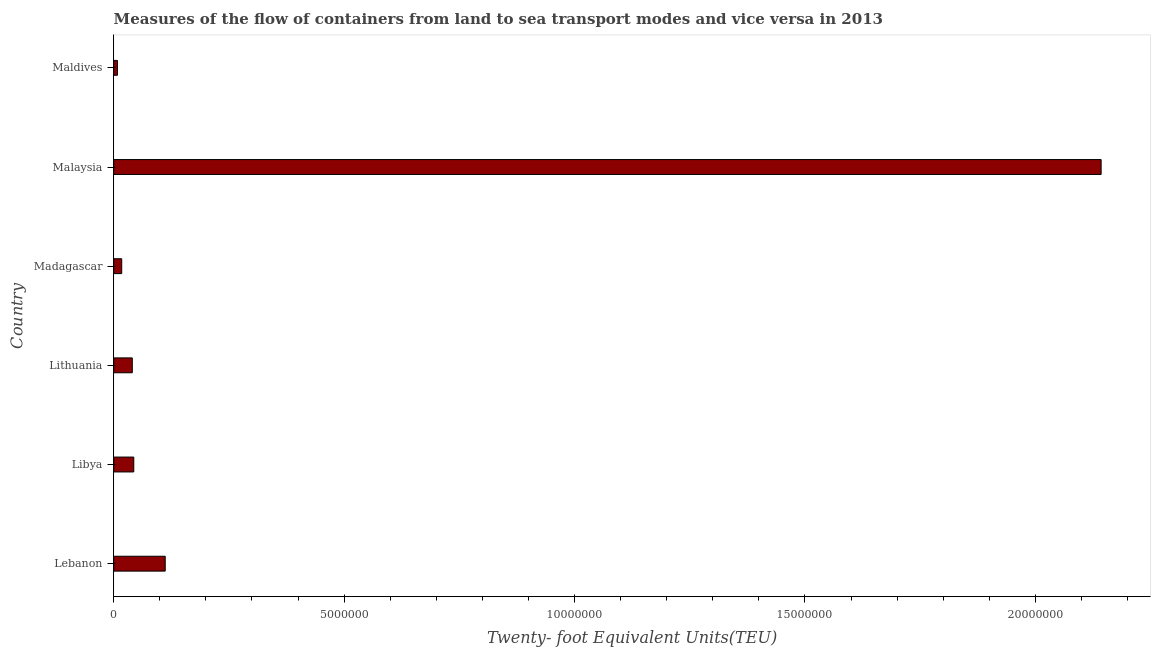Does the graph contain any zero values?
Provide a short and direct response. No. Does the graph contain grids?
Keep it short and to the point. No. What is the title of the graph?
Give a very brief answer. Measures of the flow of containers from land to sea transport modes and vice versa in 2013. What is the label or title of the X-axis?
Your answer should be very brief. Twenty- foot Equivalent Units(TEU). What is the label or title of the Y-axis?
Give a very brief answer. Country. What is the container port traffic in Lebanon?
Your answer should be very brief. 1.12e+06. Across all countries, what is the maximum container port traffic?
Your response must be concise. 2.14e+07. Across all countries, what is the minimum container port traffic?
Provide a succinct answer. 7.97e+04. In which country was the container port traffic maximum?
Give a very brief answer. Malaysia. In which country was the container port traffic minimum?
Offer a terse response. Maldives. What is the sum of the container port traffic?
Your answer should be very brief. 2.36e+07. What is the difference between the container port traffic in Lithuania and Madagascar?
Provide a short and direct response. 2.30e+05. What is the average container port traffic per country?
Make the answer very short. 3.94e+06. What is the median container port traffic?
Provide a succinct answer. 4.19e+05. In how many countries, is the container port traffic greater than 8000000 TEU?
Ensure brevity in your answer.  1. Is the container port traffic in Lebanon less than that in Malaysia?
Provide a succinct answer. Yes. Is the difference between the container port traffic in Lebanon and Malaysia greater than the difference between any two countries?
Offer a terse response. No. What is the difference between the highest and the second highest container port traffic?
Keep it short and to the point. 2.03e+07. Is the sum of the container port traffic in Lebanon and Lithuania greater than the maximum container port traffic across all countries?
Provide a short and direct response. No. What is the difference between the highest and the lowest container port traffic?
Provide a short and direct response. 2.13e+07. In how many countries, is the container port traffic greater than the average container port traffic taken over all countries?
Offer a terse response. 1. How many countries are there in the graph?
Offer a terse response. 6. What is the difference between two consecutive major ticks on the X-axis?
Your answer should be compact. 5.00e+06. What is the Twenty- foot Equivalent Units(TEU) of Lebanon?
Your answer should be very brief. 1.12e+06. What is the Twenty- foot Equivalent Units(TEU) in Libya?
Provide a short and direct response. 4.35e+05. What is the Twenty- foot Equivalent Units(TEU) of Lithuania?
Offer a very short reply. 4.02e+05. What is the Twenty- foot Equivalent Units(TEU) in Madagascar?
Keep it short and to the point. 1.73e+05. What is the Twenty- foot Equivalent Units(TEU) of Malaysia?
Offer a terse response. 2.14e+07. What is the Twenty- foot Equivalent Units(TEU) in Maldives?
Make the answer very short. 7.97e+04. What is the difference between the Twenty- foot Equivalent Units(TEU) in Lebanon and Libya?
Your response must be concise. 6.82e+05. What is the difference between the Twenty- foot Equivalent Units(TEU) in Lebanon and Lithuania?
Make the answer very short. 7.14e+05. What is the difference between the Twenty- foot Equivalent Units(TEU) in Lebanon and Madagascar?
Your answer should be compact. 9.44e+05. What is the difference between the Twenty- foot Equivalent Units(TEU) in Lebanon and Malaysia?
Offer a terse response. -2.03e+07. What is the difference between the Twenty- foot Equivalent Units(TEU) in Lebanon and Maldives?
Your answer should be very brief. 1.04e+06. What is the difference between the Twenty- foot Equivalent Units(TEU) in Libya and Lithuania?
Ensure brevity in your answer.  3.21e+04. What is the difference between the Twenty- foot Equivalent Units(TEU) in Libya and Madagascar?
Keep it short and to the point. 2.62e+05. What is the difference between the Twenty- foot Equivalent Units(TEU) in Libya and Malaysia?
Your response must be concise. -2.10e+07. What is the difference between the Twenty- foot Equivalent Units(TEU) in Libya and Maldives?
Your response must be concise. 3.55e+05. What is the difference between the Twenty- foot Equivalent Units(TEU) in Lithuania and Madagascar?
Keep it short and to the point. 2.30e+05. What is the difference between the Twenty- foot Equivalent Units(TEU) in Lithuania and Malaysia?
Your response must be concise. -2.10e+07. What is the difference between the Twenty- foot Equivalent Units(TEU) in Lithuania and Maldives?
Ensure brevity in your answer.  3.23e+05. What is the difference between the Twenty- foot Equivalent Units(TEU) in Madagascar and Malaysia?
Offer a very short reply. -2.13e+07. What is the difference between the Twenty- foot Equivalent Units(TEU) in Madagascar and Maldives?
Ensure brevity in your answer.  9.33e+04. What is the difference between the Twenty- foot Equivalent Units(TEU) in Malaysia and Maldives?
Offer a terse response. 2.13e+07. What is the ratio of the Twenty- foot Equivalent Units(TEU) in Lebanon to that in Libya?
Keep it short and to the point. 2.57. What is the ratio of the Twenty- foot Equivalent Units(TEU) in Lebanon to that in Lithuania?
Keep it short and to the point. 2.77. What is the ratio of the Twenty- foot Equivalent Units(TEU) in Lebanon to that in Madagascar?
Your response must be concise. 6.46. What is the ratio of the Twenty- foot Equivalent Units(TEU) in Lebanon to that in Malaysia?
Offer a terse response. 0.05. What is the ratio of the Twenty- foot Equivalent Units(TEU) in Lebanon to that in Maldives?
Offer a very short reply. 14.01. What is the ratio of the Twenty- foot Equivalent Units(TEU) in Libya to that in Madagascar?
Keep it short and to the point. 2.51. What is the ratio of the Twenty- foot Equivalent Units(TEU) in Libya to that in Maldives?
Ensure brevity in your answer.  5.45. What is the ratio of the Twenty- foot Equivalent Units(TEU) in Lithuania to that in Madagascar?
Provide a succinct answer. 2.33. What is the ratio of the Twenty- foot Equivalent Units(TEU) in Lithuania to that in Malaysia?
Offer a terse response. 0.02. What is the ratio of the Twenty- foot Equivalent Units(TEU) in Lithuania to that in Maldives?
Ensure brevity in your answer.  5.05. What is the ratio of the Twenty- foot Equivalent Units(TEU) in Madagascar to that in Malaysia?
Offer a terse response. 0.01. What is the ratio of the Twenty- foot Equivalent Units(TEU) in Madagascar to that in Maldives?
Your answer should be compact. 2.17. What is the ratio of the Twenty- foot Equivalent Units(TEU) in Malaysia to that in Maldives?
Your response must be concise. 268.8. 